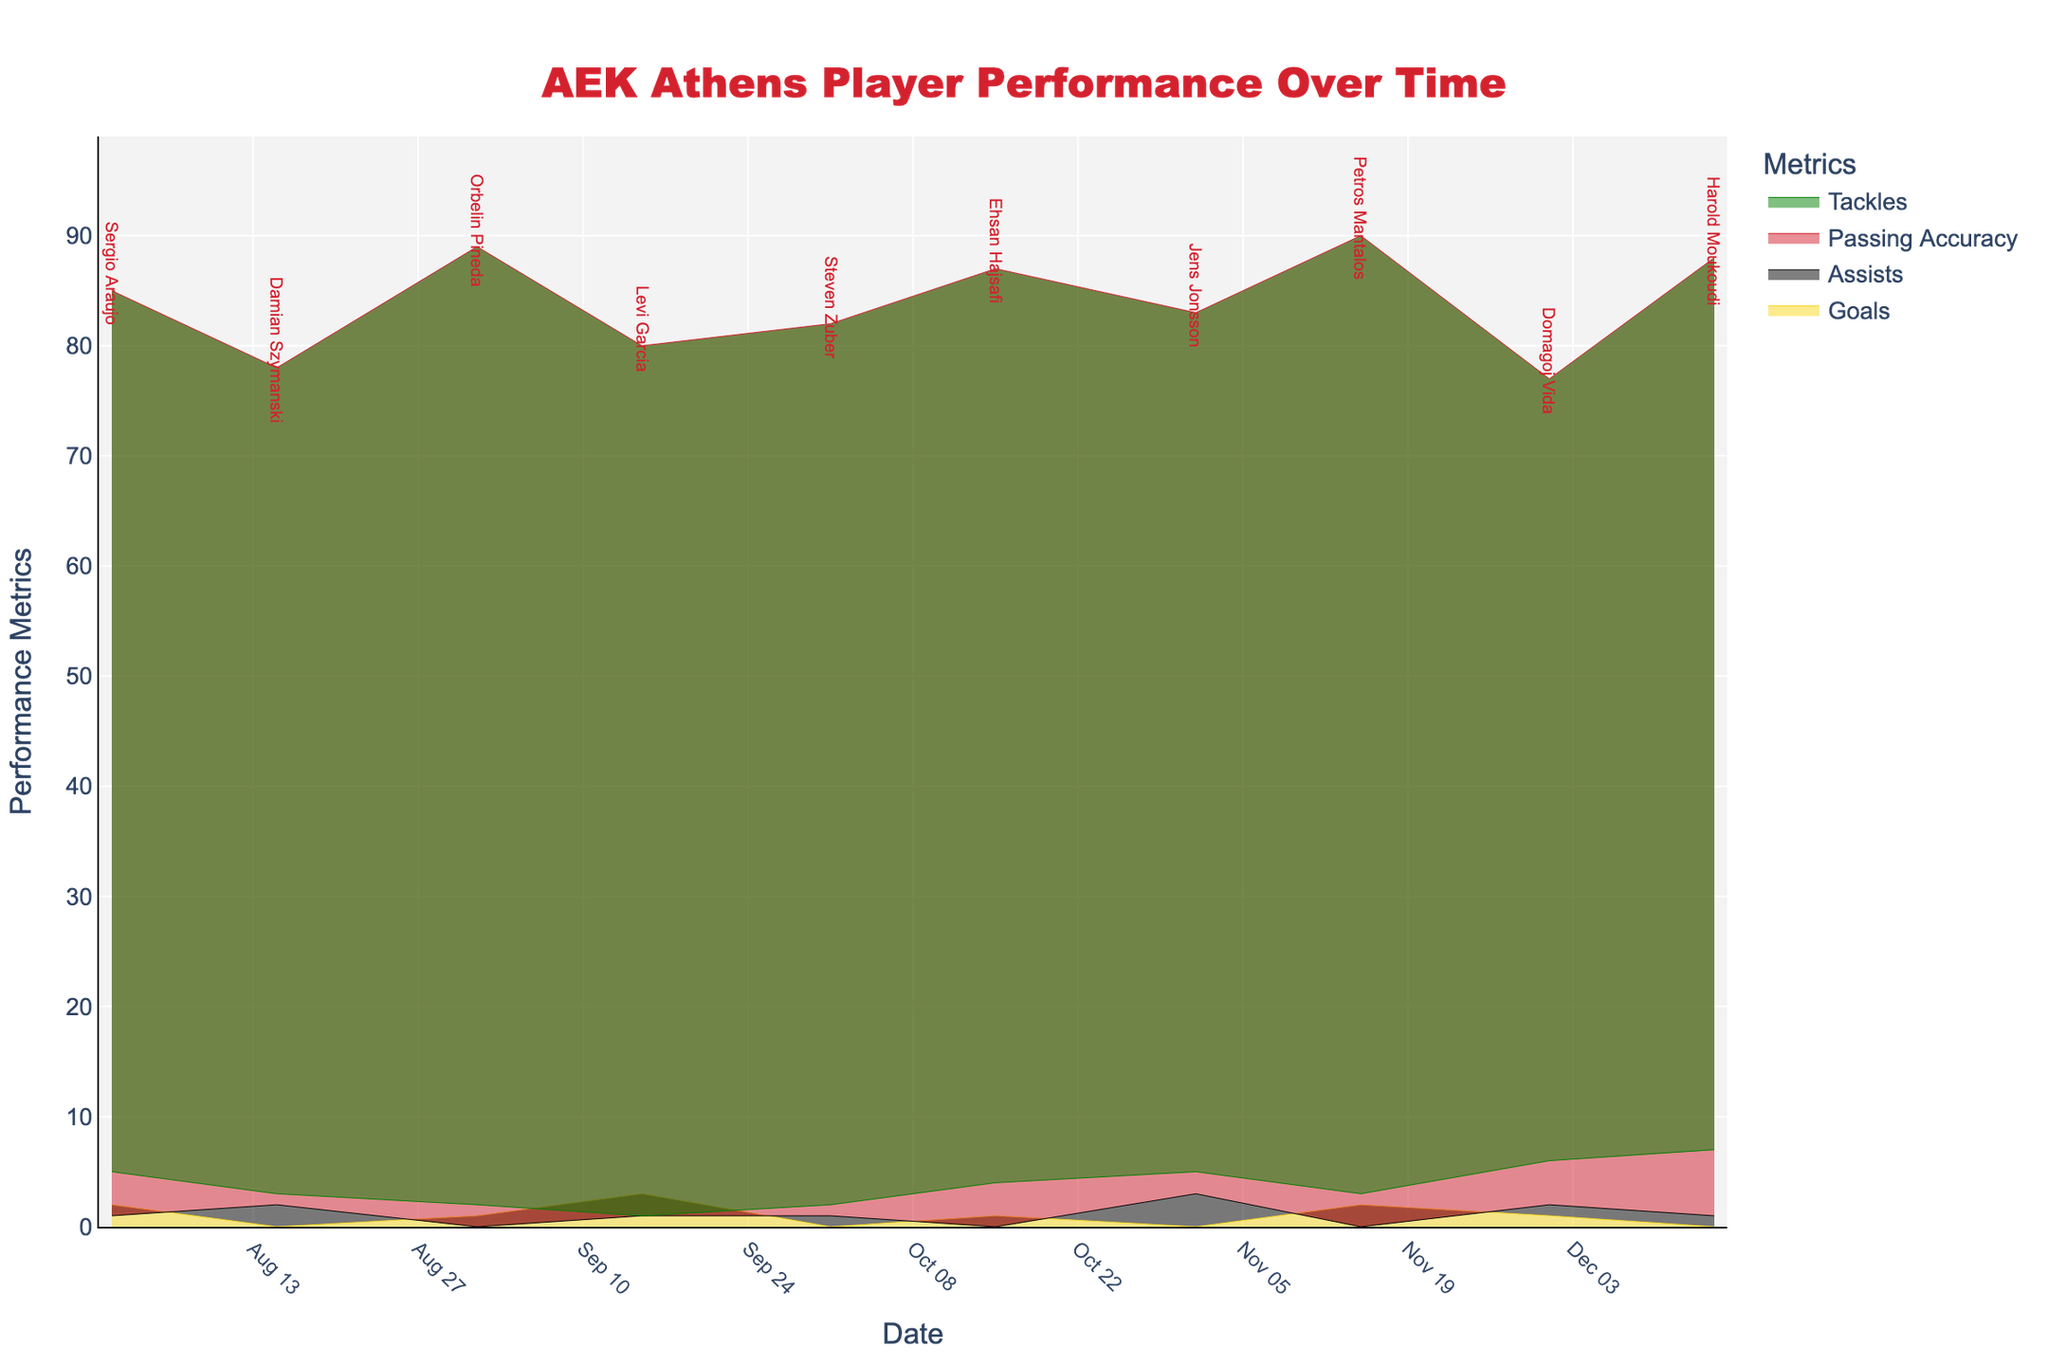What's the title of the plot? The title is displayed prominently at the top of the chart. It reads "AEK Athens Player Performance Over Time" with specific font settings and color.
Answer: AEK Athens Player Performance Over Time How many different performance metrics are displayed in the chart? By referring to the legend on the right side of the chart, four performance metrics are listed: Goals, Assists, Passing Accuracy, and Tackles.
Answer: Four Which player achieved the highest goals in a single game shown in the chart? By looking at the data points and annotations, Levi Garcia scored the highest goals with 3 goals on September 15.
Answer: Levi Garcia What's the passing accuracy of Petros Mantalos on November 15? By looking at the hover template or the specific point related to Petros Mantalos' annotation, it shows a passing accuracy of 90% for that date.
Answer: 90% Which metric has the lowest value throughout the entire season? By analyzing all the areas in the step area chart, Tackles generally have the lowest values.
Answer: Tackles Compare the total assists made by Damian Szymanski and Jens Jonsson. Who recorded more assists? By checking the individual assist values from the plotted points and annotations, Damian Szymanski had 2 assists, while Jens Jonsson had 3 assists.
Answer: Jens Jonsson What's the range of dates covered in the chart? The data points start from August 1 and extend to December 15, visible on the x-axis of the chart.
Answer: August 1 to December 15 Which metric shows the most improvement in the last month of the season when comparing early November and early December? By comparing the filled areas for November 1 and December 1, Tackles show significant improvement from Jens Jonsson’s 5 (Nov 1) to Domagoj Vida’s 6 (Dec 1).
Answer: Tackles Who is the player with the highest passing accuracy, and what is that accuracy? By checking all the passing accuracy values and respective annotations, Petros Mantalos on November 15 achieved the highest passing accuracy of 90%.
Answer: Petros Mantalos with 90% How many tackles did Harold Moukoudi make on December 15? According to the annotation and corresponding data for Harold Moukoudi, he made 7 tackles on December 15.
Answer: 7 